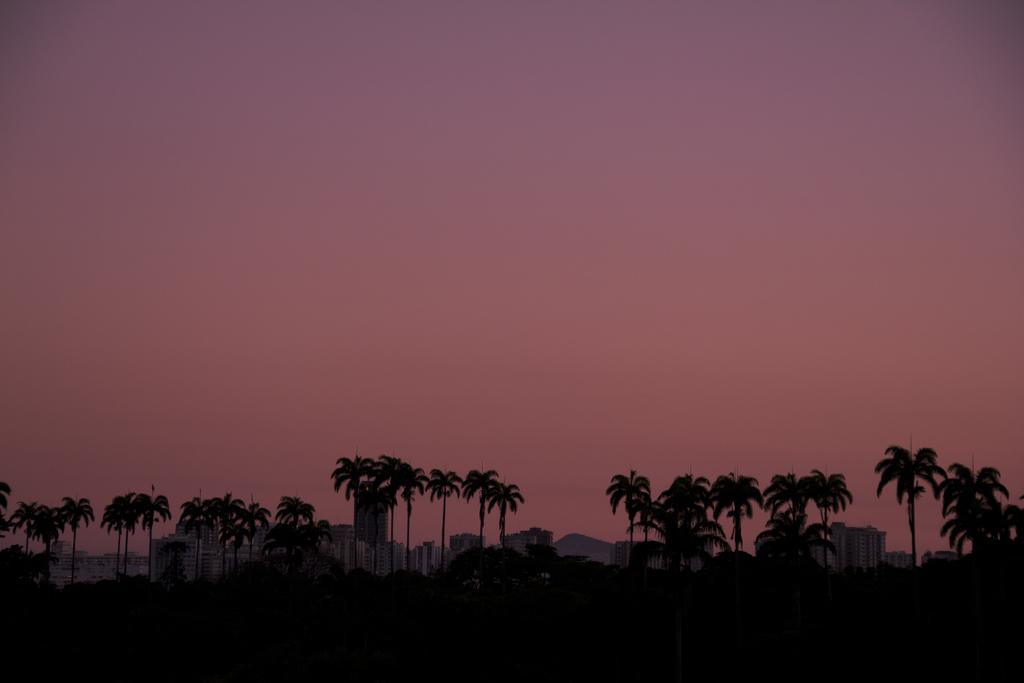What type of natural vegetation can be seen in the image? There are trees in the image. What type of man-made structures are present in the image? There are buildings in the image. What is visible at the top of the image? The sky is visible at the top of the image. Where is the honey stored in the image? There is no honey present in the image. What type of control panel can be seen in the image? There is no control panel present in the image. 